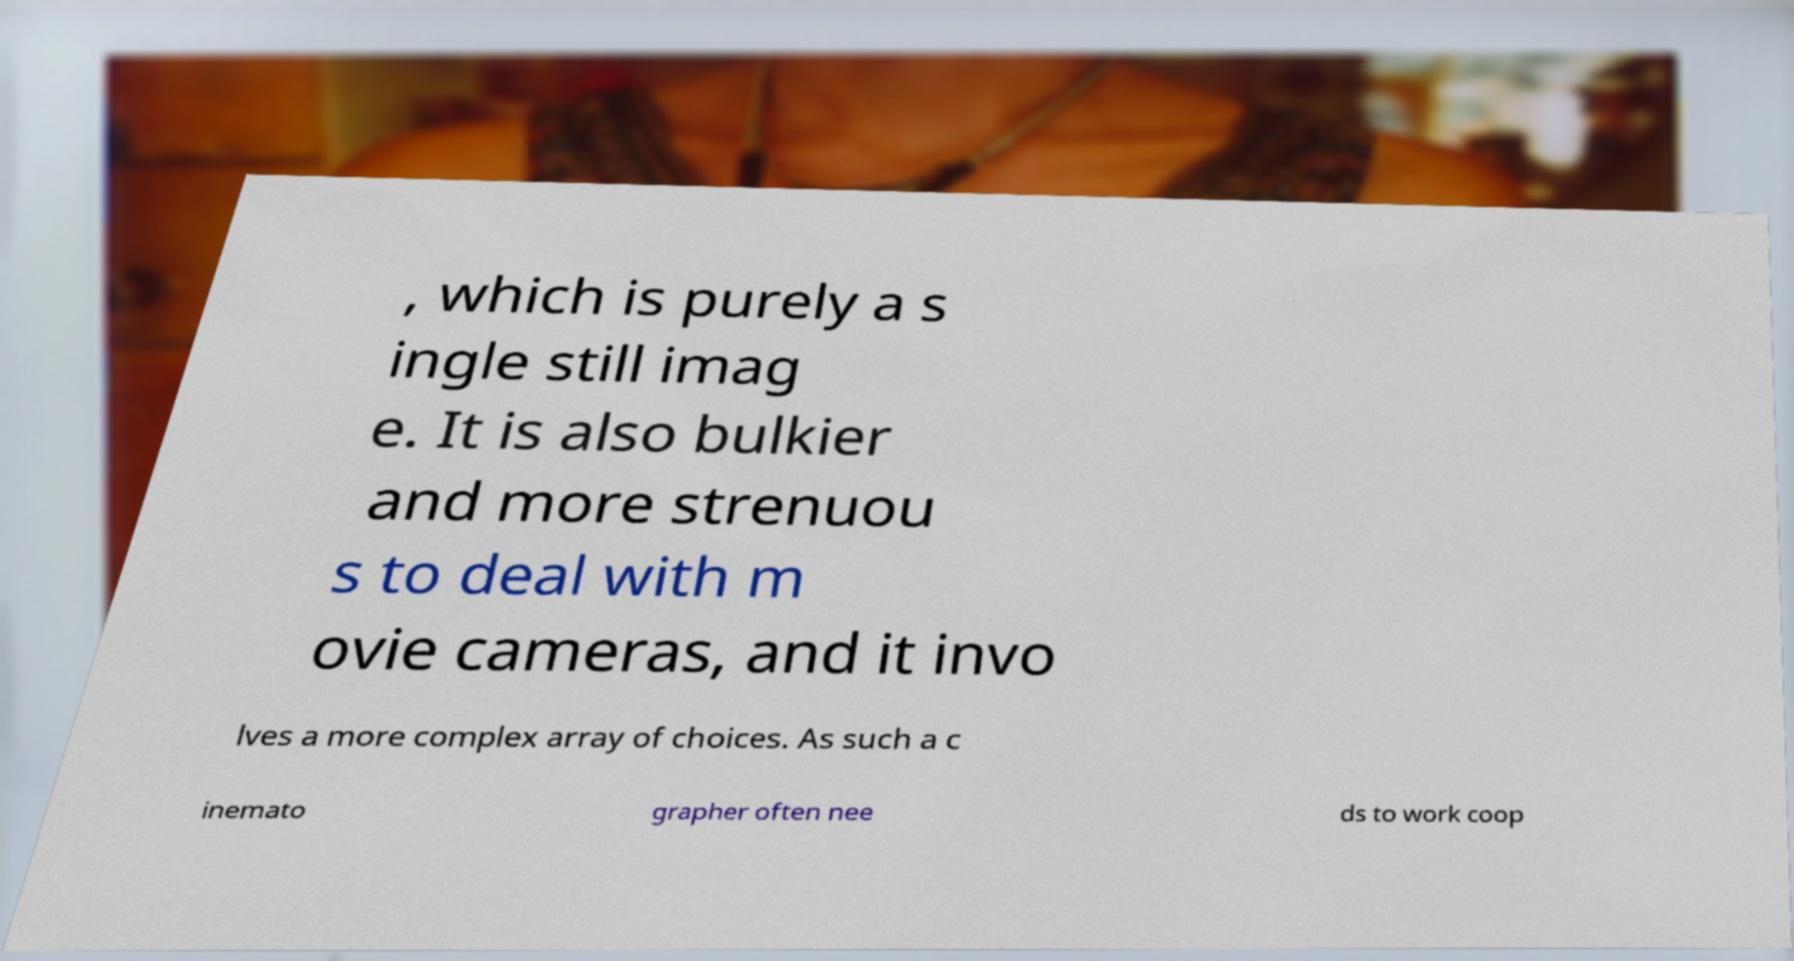Could you extract and type out the text from this image? , which is purely a s ingle still imag e. It is also bulkier and more strenuou s to deal with m ovie cameras, and it invo lves a more complex array of choices. As such a c inemato grapher often nee ds to work coop 